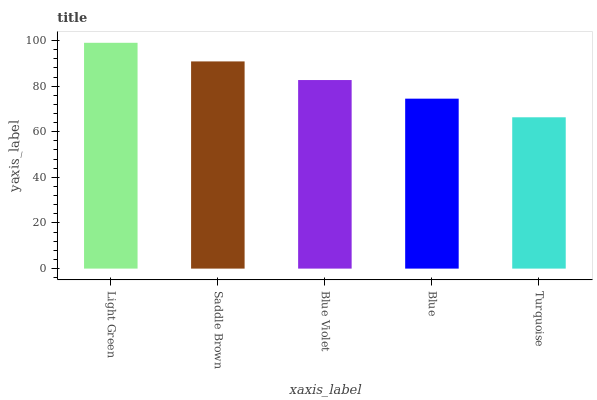Is Turquoise the minimum?
Answer yes or no. Yes. Is Light Green the maximum?
Answer yes or no. Yes. Is Saddle Brown the minimum?
Answer yes or no. No. Is Saddle Brown the maximum?
Answer yes or no. No. Is Light Green greater than Saddle Brown?
Answer yes or no. Yes. Is Saddle Brown less than Light Green?
Answer yes or no. Yes. Is Saddle Brown greater than Light Green?
Answer yes or no. No. Is Light Green less than Saddle Brown?
Answer yes or no. No. Is Blue Violet the high median?
Answer yes or no. Yes. Is Blue Violet the low median?
Answer yes or no. Yes. Is Light Green the high median?
Answer yes or no. No. Is Turquoise the low median?
Answer yes or no. No. 